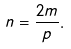Convert formula to latex. <formula><loc_0><loc_0><loc_500><loc_500>n = \frac { 2 m } { p } .</formula> 